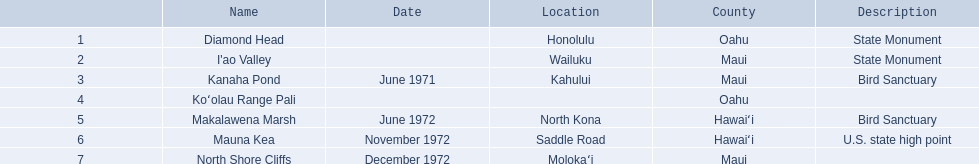What are the national natural landmarks in hawaii? Diamond Head, I'ao Valley, Kanaha Pond, Koʻolau Range Pali, Makalawena Marsh, Mauna Kea, North Shore Cliffs. Which of theses are in hawa'i county? Makalawena Marsh, Mauna Kea. Of these which has a bird sanctuary? Makalawena Marsh. 